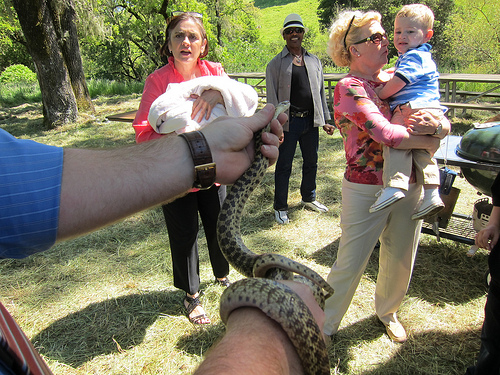<image>
Is there a snake on the ground? No. The snake is not positioned on the ground. They may be near each other, but the snake is not supported by or resting on top of the ground. Where is the man in relation to the snake? Is it on the snake? No. The man is not positioned on the snake. They may be near each other, but the man is not supported by or resting on top of the snake. 